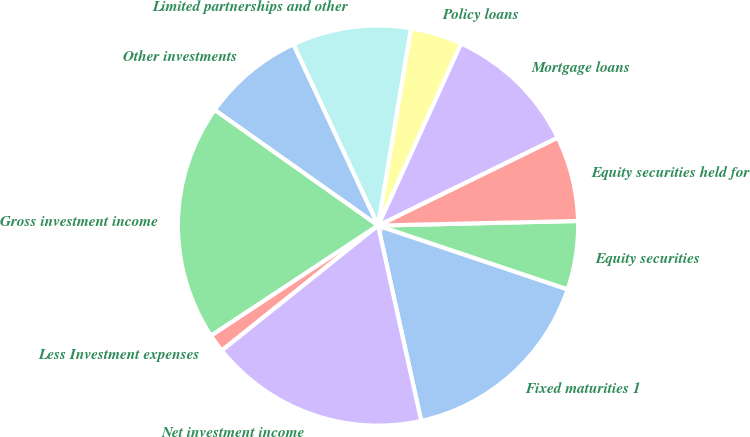Convert chart. <chart><loc_0><loc_0><loc_500><loc_500><pie_chart><fcel>Fixed maturities 1<fcel>Equity securities<fcel>Equity securities held for<fcel>Mortgage loans<fcel>Policy loans<fcel>Limited partnerships and other<fcel>Other investments<fcel>Gross investment income<fcel>Less Investment expenses<fcel>Net investment income<nl><fcel>16.37%<fcel>5.53%<fcel>6.88%<fcel>10.95%<fcel>4.17%<fcel>9.59%<fcel>8.24%<fcel>19.08%<fcel>1.46%<fcel>17.72%<nl></chart> 